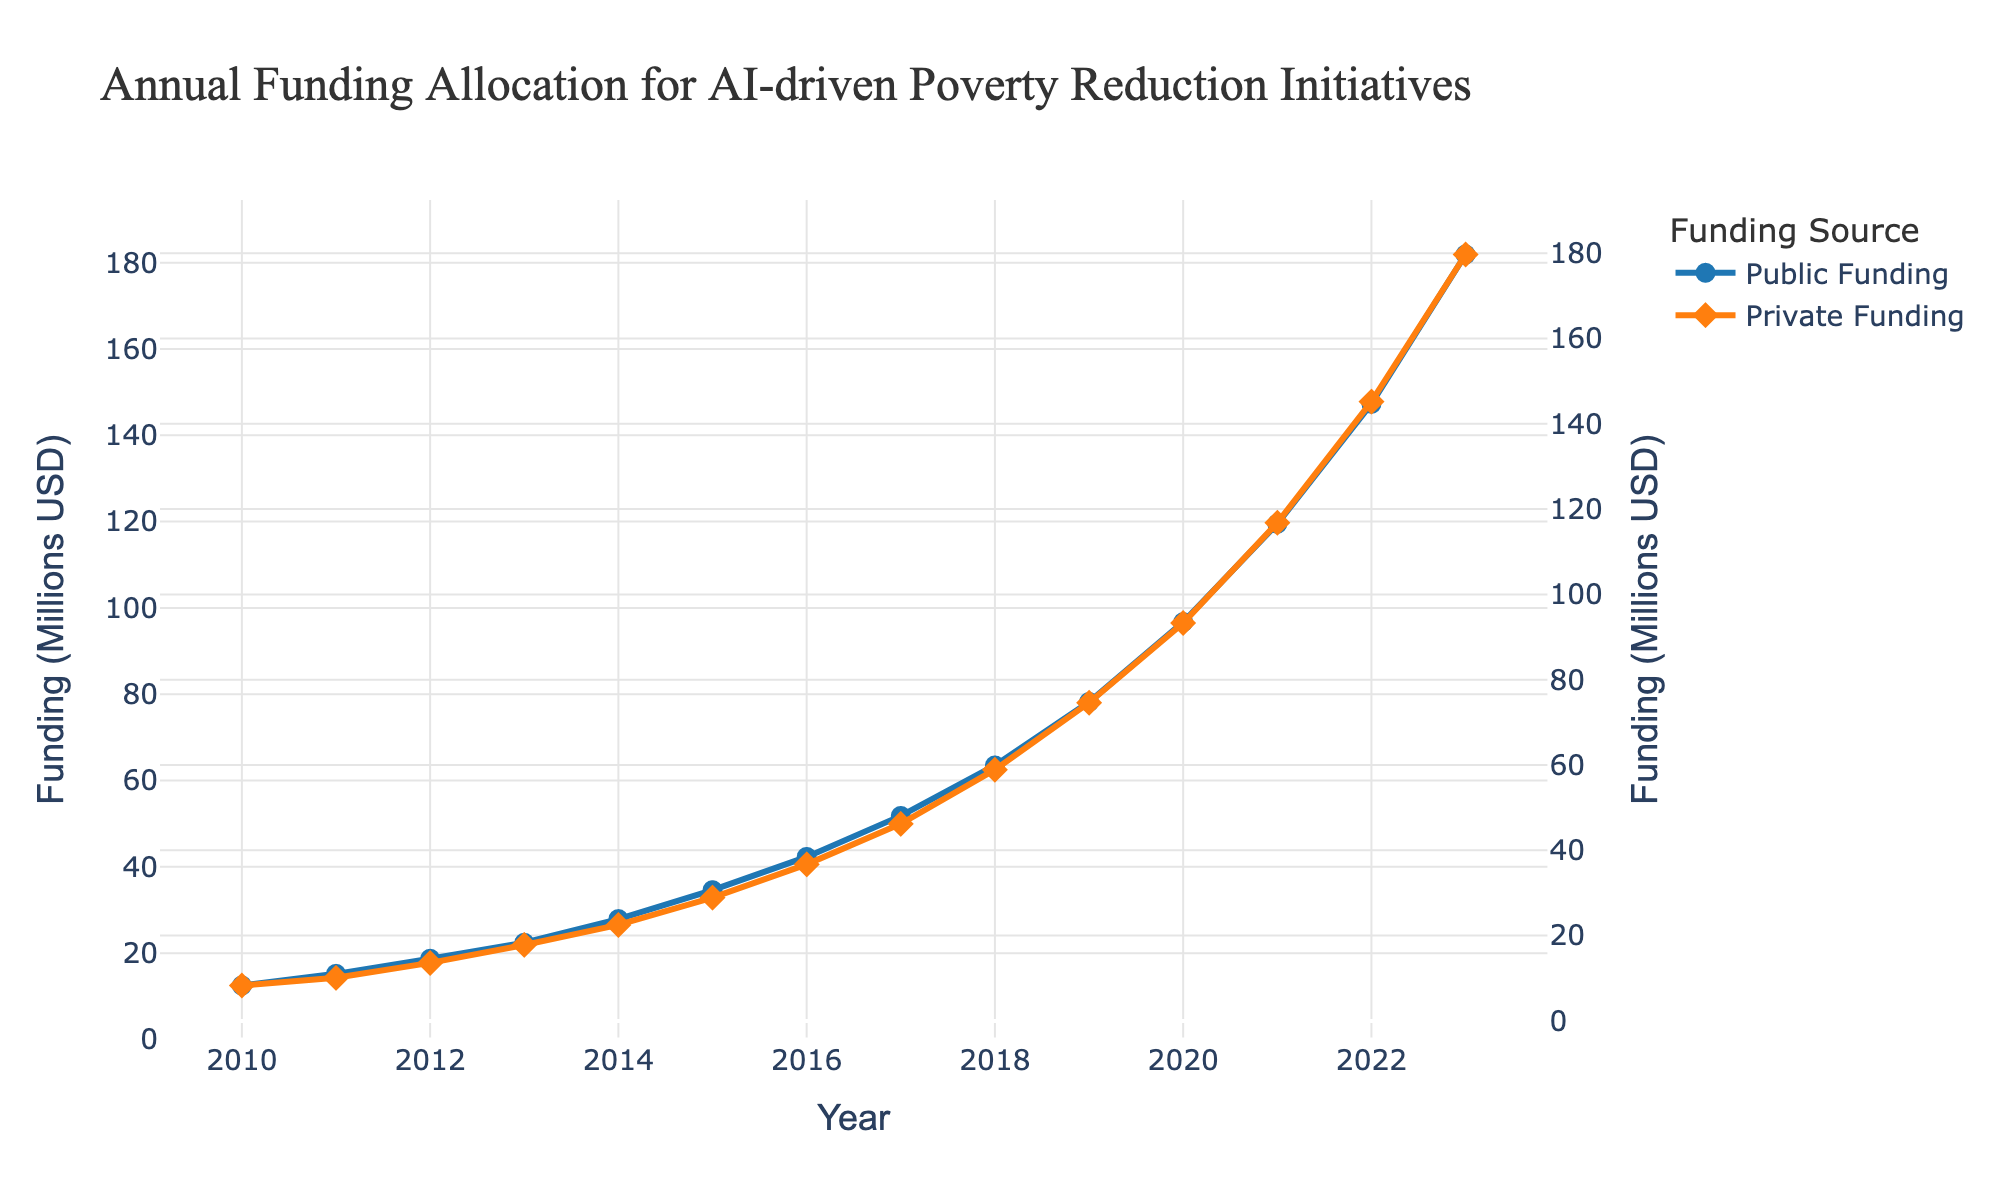What is the difference in public funding between the years 2010 and 2020? Public funding in 2010 was 12.5 million USD and in 2020 it was 96.7 million USD. The difference is calculated as 96.7 - 12.5.
Answer: 84.2 million USD In which year did private funding first exceed 100 million USD? By examining the private funding line, we observe that the funding surpasses 100 million USD for the first time in 2021.
Answer: 2021 What's the sum of public and private funding in 2023? Public funding in 2023 is 181.9 million USD and private funding is 179.7 million USD. The sum is 181.9 + 179.7.
Answer: 361.6 million USD Which funding source experienced a higher growth rate from 2010 to 2023? The public funding grew from 12.5 million USD to 181.9 million USD, and private funding grew from 8.3 million USD to 179.7 million USD. The growth rate for public funding is ((181.9 - 12.5) / 12.5) * 100% and for private funding it is ((179.7 - 8.3) / 8.3) * 100%. By comparing these percentages, it is evident that private funding experienced a higher growth rate.
Answer: Private funding During which year did the difference between public and private funding amounts reach its maximum? By analyzing the gap between the two funding lines over the years, the maximum difference was observed in 2016, where public funding was 42.3 million USD and private funding was 36.7 million USD, resulting in a difference of 5.6 million USD.
Answer: 2016 What is the average annual public funding over the period 2010-2023? Sum the public funding values from 2010 to 2023 and then divide by the number of years (14). The sum is 922.9 million USD, and the average is 922.9 / 14.
Answer: 65.9 million USD Are there any years where public funding and private funding were equal? By looking at the lines on the chart, we note that there are no points where the public and private funding lines intersect, thus funding amounts were never equal in any year.
Answer: No How much did private funding increase from 2018 to 2019? Private funding increased from 58.9 million USD in 2018 to 74.6 million USD in 2019. The increase is calculated as 74.6 - 58.9.
Answer: 15.7 million USD What visual distinction is used to differentiate between public and private funding lines? The public funding line is represented with circles and a blue color, while the private funding line is represented with diamonds and an orange color.
Answer: Color and marker shape Which funding source had a steeper increase in funding in the year 2020? Comparing the slopes of the lines from 2019 to 2020, public funding increased from 78.2 million USD to 96.7 million USD, a difference of 18.5 million USD, and private funding increased from 74.6 million USD to 93.3 million USD, a difference of 18.7 million USD. The steeper increase is observed in private funding.
Answer: Private funding 